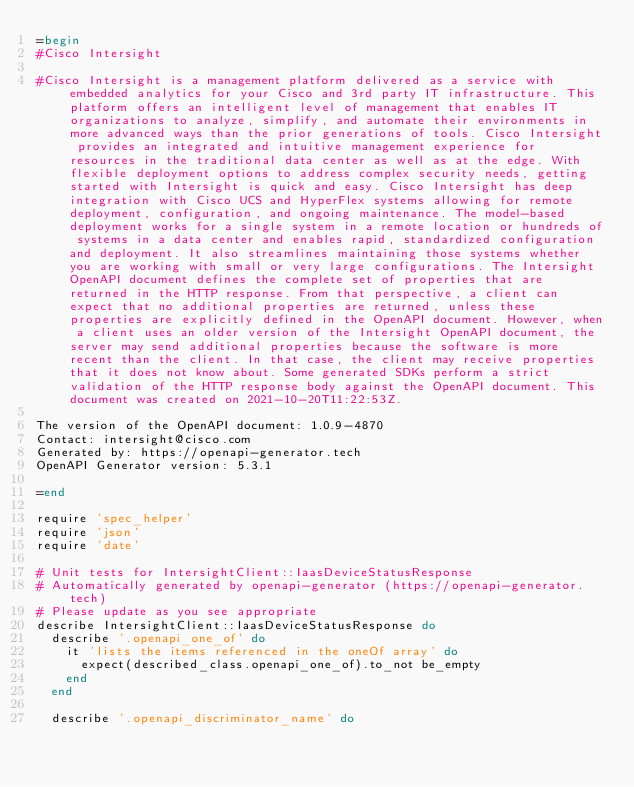Convert code to text. <code><loc_0><loc_0><loc_500><loc_500><_Ruby_>=begin
#Cisco Intersight

#Cisco Intersight is a management platform delivered as a service with embedded analytics for your Cisco and 3rd party IT infrastructure. This platform offers an intelligent level of management that enables IT organizations to analyze, simplify, and automate their environments in more advanced ways than the prior generations of tools. Cisco Intersight provides an integrated and intuitive management experience for resources in the traditional data center as well as at the edge. With flexible deployment options to address complex security needs, getting started with Intersight is quick and easy. Cisco Intersight has deep integration with Cisco UCS and HyperFlex systems allowing for remote deployment, configuration, and ongoing maintenance. The model-based deployment works for a single system in a remote location or hundreds of systems in a data center and enables rapid, standardized configuration and deployment. It also streamlines maintaining those systems whether you are working with small or very large configurations. The Intersight OpenAPI document defines the complete set of properties that are returned in the HTTP response. From that perspective, a client can expect that no additional properties are returned, unless these properties are explicitly defined in the OpenAPI document. However, when a client uses an older version of the Intersight OpenAPI document, the server may send additional properties because the software is more recent than the client. In that case, the client may receive properties that it does not know about. Some generated SDKs perform a strict validation of the HTTP response body against the OpenAPI document. This document was created on 2021-10-20T11:22:53Z.

The version of the OpenAPI document: 1.0.9-4870
Contact: intersight@cisco.com
Generated by: https://openapi-generator.tech
OpenAPI Generator version: 5.3.1

=end

require 'spec_helper'
require 'json'
require 'date'

# Unit tests for IntersightClient::IaasDeviceStatusResponse
# Automatically generated by openapi-generator (https://openapi-generator.tech)
# Please update as you see appropriate
describe IntersightClient::IaasDeviceStatusResponse do
  describe '.openapi_one_of' do
    it 'lists the items referenced in the oneOf array' do
      expect(described_class.openapi_one_of).to_not be_empty
    end
  end

  describe '.openapi_discriminator_name' do</code> 